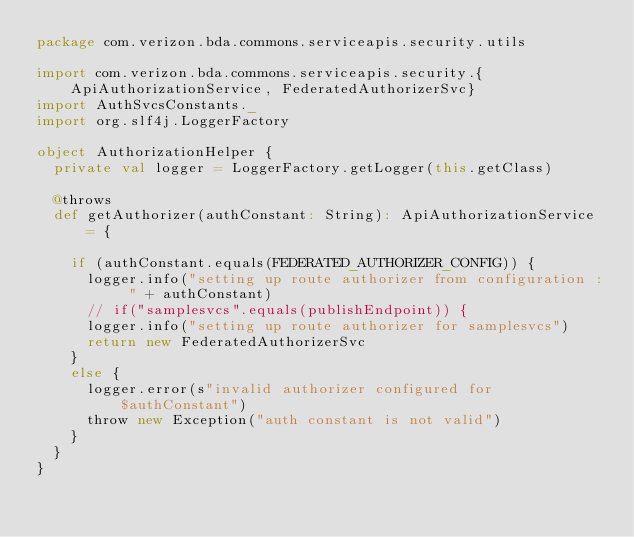Convert code to text. <code><loc_0><loc_0><loc_500><loc_500><_Scala_>package com.verizon.bda.commons.serviceapis.security.utils

import com.verizon.bda.commons.serviceapis.security.{ApiAuthorizationService, FederatedAuthorizerSvc}
import AuthSvcsConstants._
import org.slf4j.LoggerFactory

object AuthorizationHelper {
  private val logger = LoggerFactory.getLogger(this.getClass)

  @throws
  def getAuthorizer(authConstant: String): ApiAuthorizationService = {

    if (authConstant.equals(FEDERATED_AUTHORIZER_CONFIG)) {
      logger.info("setting up route authorizer from configuration : " + authConstant)
      // if("samplesvcs".equals(publishEndpoint)) {
      logger.info("setting up route authorizer for samplesvcs")
      return new FederatedAuthorizerSvc
    }
    else {
      logger.error(s"invalid authorizer configured for $authConstant")
      throw new Exception("auth constant is not valid")
    }
  }
}
</code> 